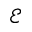<formula> <loc_0><loc_0><loc_500><loc_500>\mathcal { E }</formula> 